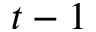Convert formula to latex. <formula><loc_0><loc_0><loc_500><loc_500>t - 1</formula> 